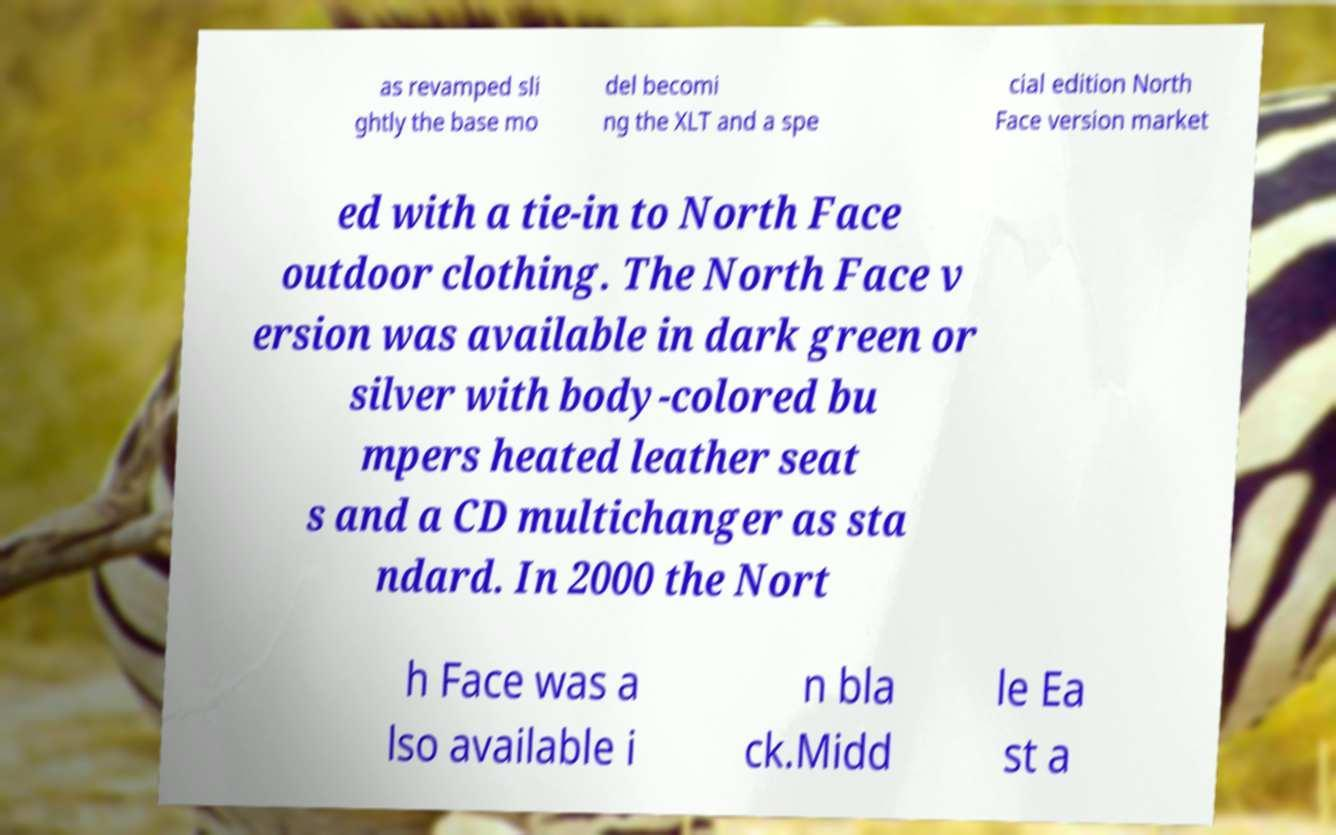Could you assist in decoding the text presented in this image and type it out clearly? as revamped sli ghtly the base mo del becomi ng the XLT and a spe cial edition North Face version market ed with a tie-in to North Face outdoor clothing. The North Face v ersion was available in dark green or silver with body-colored bu mpers heated leather seat s and a CD multichanger as sta ndard. In 2000 the Nort h Face was a lso available i n bla ck.Midd le Ea st a 